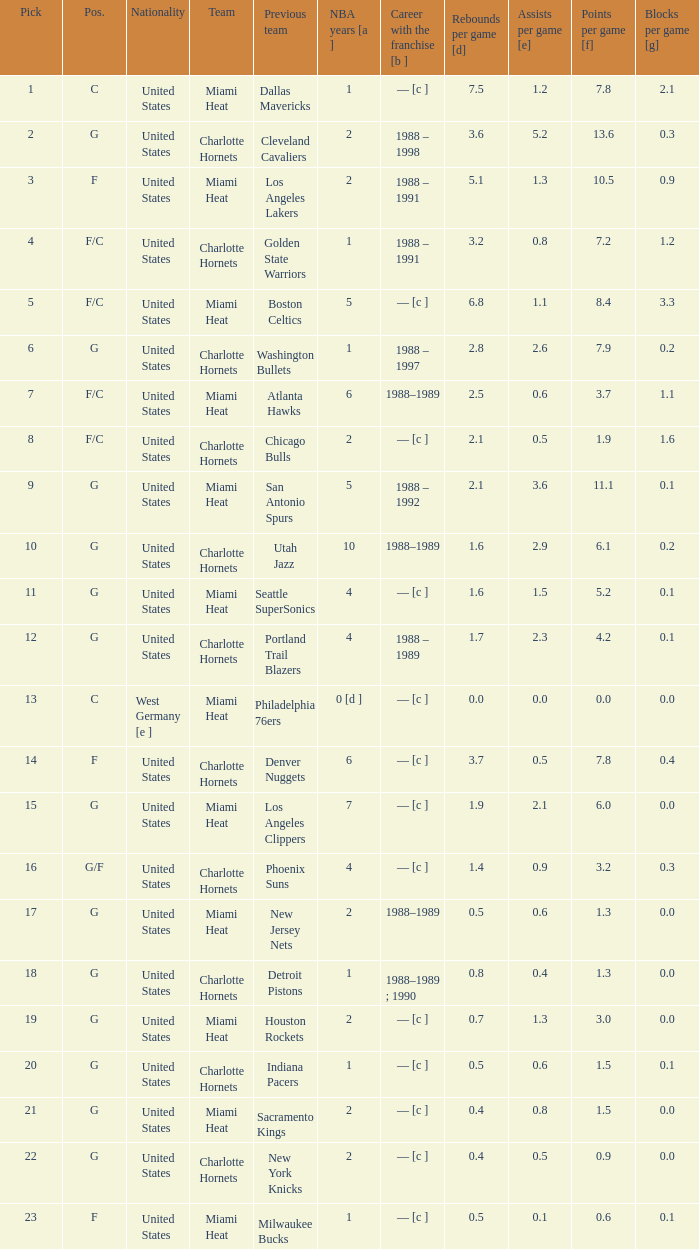What is the team of the player who was previously on the indiana pacers? Charlotte Hornets. Can you parse all the data within this table? {'header': ['Pick', 'Pos.', 'Nationality', 'Team', 'Previous team', 'NBA years [a ]', 'Career with the franchise [b ]', 'Rebounds per game [d]', 'Assists per game [e]', 'Points per game [f]', 'Blocks per game [g]'], 'rows': [['1', 'C', 'United States', 'Miami Heat', 'Dallas Mavericks', '1', '— [c ]', '7.5', '1.2', '7.8', '2.1'], ['2', 'G', 'United States', 'Charlotte Hornets', 'Cleveland Cavaliers', '2', '1988 – 1998', '3.6', '5.2', '13.6', '0.3'], ['3', 'F', 'United States', 'Miami Heat', 'Los Angeles Lakers', '2', '1988 – 1991', '5.1', '1.3', '10.5', '0.9'], ['4', 'F/C', 'United States', 'Charlotte Hornets', 'Golden State Warriors', '1', '1988 – 1991', '3.2', '0.8', '7.2', '1.2'], ['5', 'F/C', 'United States', 'Miami Heat', 'Boston Celtics', '5', '— [c ]', '6.8', '1.1', '8.4', '3.3'], ['6', 'G', 'United States', 'Charlotte Hornets', 'Washington Bullets', '1', '1988 – 1997', '2.8', '2.6', '7.9', '0.2'], ['7', 'F/C', 'United States', 'Miami Heat', 'Atlanta Hawks', '6', '1988–1989', '2.5', '0.6', '3.7', '1.1'], ['8', 'F/C', 'United States', 'Charlotte Hornets', 'Chicago Bulls', '2', '— [c ]', '2.1', '0.5', '1.9', '1.6'], ['9', 'G', 'United States', 'Miami Heat', 'San Antonio Spurs', '5', '1988 – 1992', '2.1', '3.6', '11.1', '0.1'], ['10', 'G', 'United States', 'Charlotte Hornets', 'Utah Jazz', '10', '1988–1989', '1.6', '2.9', '6.1', '0.2'], ['11', 'G', 'United States', 'Miami Heat', 'Seattle SuperSonics', '4', '— [c ]', '1.6', '1.5', '5.2', '0.1'], ['12', 'G', 'United States', 'Charlotte Hornets', 'Portland Trail Blazers', '4', '1988 – 1989', '1.7', '2.3', '4.2', '0.1'], ['13', 'C', 'West Germany [e ]', 'Miami Heat', 'Philadelphia 76ers', '0 [d ]', '— [c ]', '0.0', '0.0', '0.0', '0.0'], ['14', 'F', 'United States', 'Charlotte Hornets', 'Denver Nuggets', '6', '— [c ]', '3.7', '0.5', '7.8', '0.4'], ['15', 'G', 'United States', 'Miami Heat', 'Los Angeles Clippers', '7', '— [c ]', '1.9', '2.1', '6.0', '0.0'], ['16', 'G/F', 'United States', 'Charlotte Hornets', 'Phoenix Suns', '4', '— [c ]', '1.4', '0.9', '3.2', '0.3'], ['17', 'G', 'United States', 'Miami Heat', 'New Jersey Nets', '2', '1988–1989', '0.5', '0.6', '1.3', '0.0'], ['18', 'G', 'United States', 'Charlotte Hornets', 'Detroit Pistons', '1', '1988–1989 ; 1990', '0.8', '0.4', '1.3', '0.0'], ['19', 'G', 'United States', 'Miami Heat', 'Houston Rockets', '2', '— [c ]', '0.7', '1.3', '3.0', '0.0'], ['20', 'G', 'United States', 'Charlotte Hornets', 'Indiana Pacers', '1', '— [c ]', '0.5', '0.6', '1.5', '0.1'], ['21', 'G', 'United States', 'Miami Heat', 'Sacramento Kings', '2', '— [c ]', '0.4', '0.8', '1.5', '0.0'], ['22', 'G', 'United States', 'Charlotte Hornets', 'New York Knicks', '2', '— [c ]', '0.4', '0.5', '0.9', '0.0'], ['23', 'F', 'United States', 'Miami Heat', 'Milwaukee Bucks', '1', '— [c ]', '0.5', '0.1', '0.6', '0.1']]} 